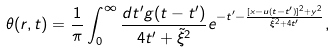Convert formula to latex. <formula><loc_0><loc_0><loc_500><loc_500>\theta ( { r } , t ) = \frac { 1 } { \pi } \int _ { 0 } ^ { \infty } \frac { d t ^ { \prime } g ( t - t ^ { \prime } ) } { 4 t ^ { \prime } + { \tilde { \xi } } ^ { 2 } } e ^ { - t ^ { \prime } - \frac { [ x - u ( t - t ^ { \prime } ) ] ^ { 2 } + y ^ { 2 } } { { \tilde { \xi } } ^ { 2 } + 4 t ^ { \prime } } } ,</formula> 